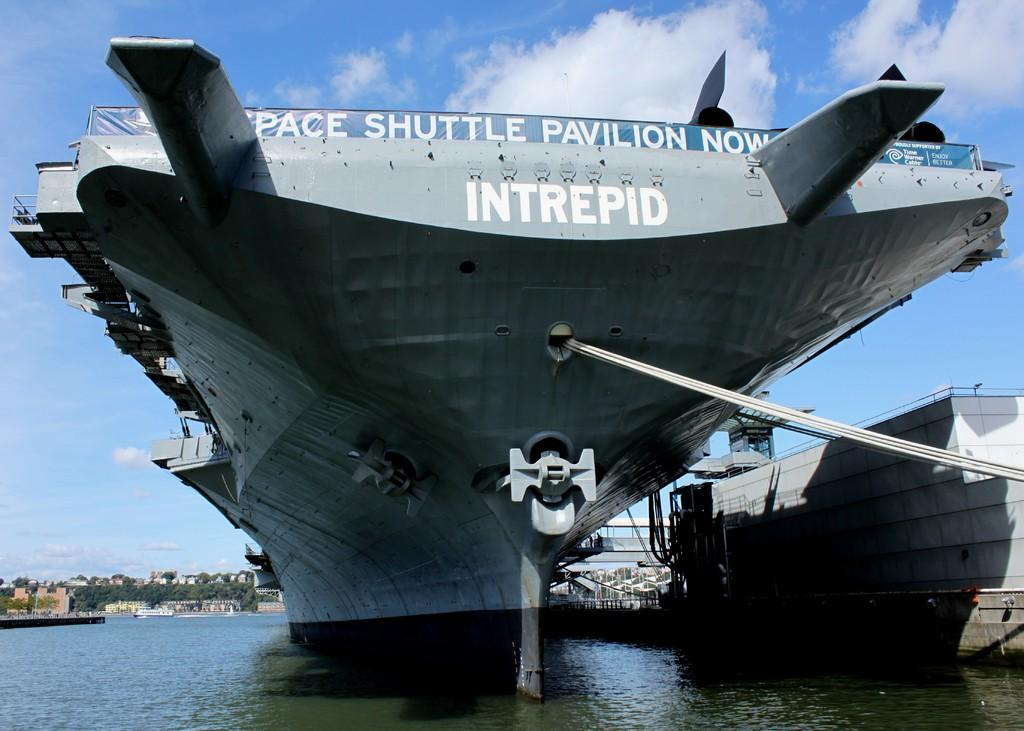<image>
Give a short and clear explanation of the subsequent image. A large air craft carrier named the Intrepid sits on the water. 